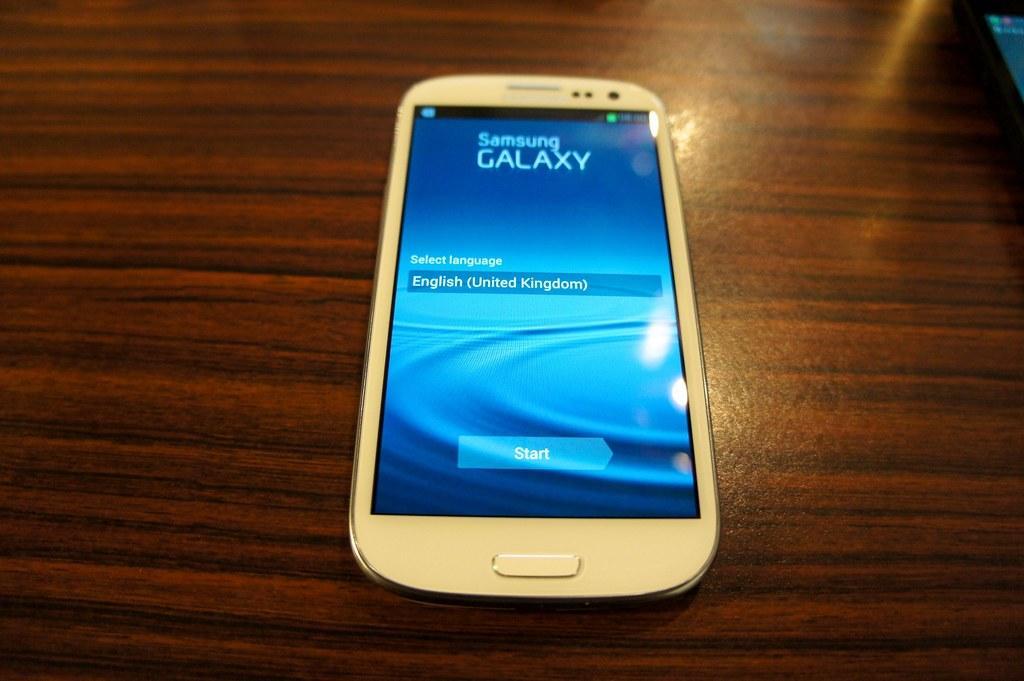Could you give a brief overview of what you see in this image? In the center of the image there is a table. On the table a mobile is there. 